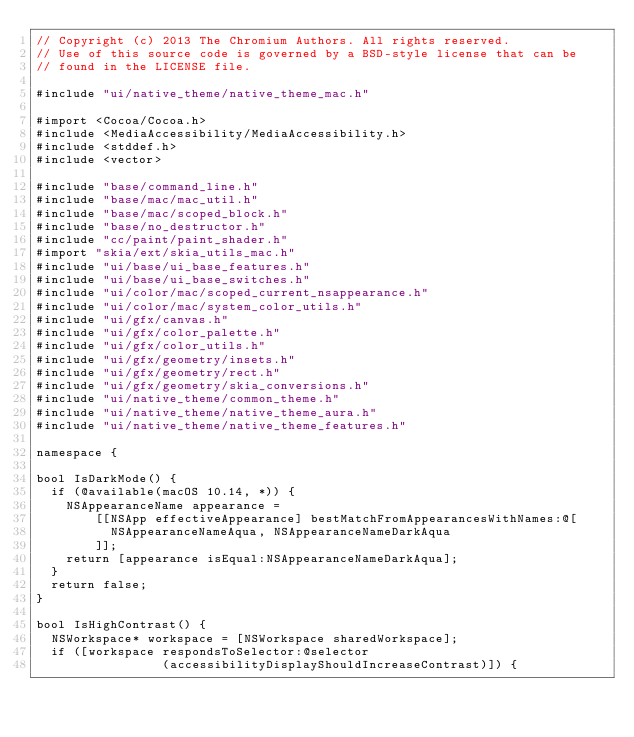<code> <loc_0><loc_0><loc_500><loc_500><_ObjectiveC_>// Copyright (c) 2013 The Chromium Authors. All rights reserved.
// Use of this source code is governed by a BSD-style license that can be
// found in the LICENSE file.

#include "ui/native_theme/native_theme_mac.h"

#import <Cocoa/Cocoa.h>
#include <MediaAccessibility/MediaAccessibility.h>
#include <stddef.h>
#include <vector>

#include "base/command_line.h"
#include "base/mac/mac_util.h"
#include "base/mac/scoped_block.h"
#include "base/no_destructor.h"
#include "cc/paint/paint_shader.h"
#import "skia/ext/skia_utils_mac.h"
#include "ui/base/ui_base_features.h"
#include "ui/base/ui_base_switches.h"
#include "ui/color/mac/scoped_current_nsappearance.h"
#include "ui/color/mac/system_color_utils.h"
#include "ui/gfx/canvas.h"
#include "ui/gfx/color_palette.h"
#include "ui/gfx/color_utils.h"
#include "ui/gfx/geometry/insets.h"
#include "ui/gfx/geometry/rect.h"
#include "ui/gfx/geometry/skia_conversions.h"
#include "ui/native_theme/common_theme.h"
#include "ui/native_theme/native_theme_aura.h"
#include "ui/native_theme/native_theme_features.h"

namespace {

bool IsDarkMode() {
  if (@available(macOS 10.14, *)) {
    NSAppearanceName appearance =
        [[NSApp effectiveAppearance] bestMatchFromAppearancesWithNames:@[
          NSAppearanceNameAqua, NSAppearanceNameDarkAqua
        ]];
    return [appearance isEqual:NSAppearanceNameDarkAqua];
  }
  return false;
}

bool IsHighContrast() {
  NSWorkspace* workspace = [NSWorkspace sharedWorkspace];
  if ([workspace respondsToSelector:@selector
                 (accessibilityDisplayShouldIncreaseContrast)]) {</code> 